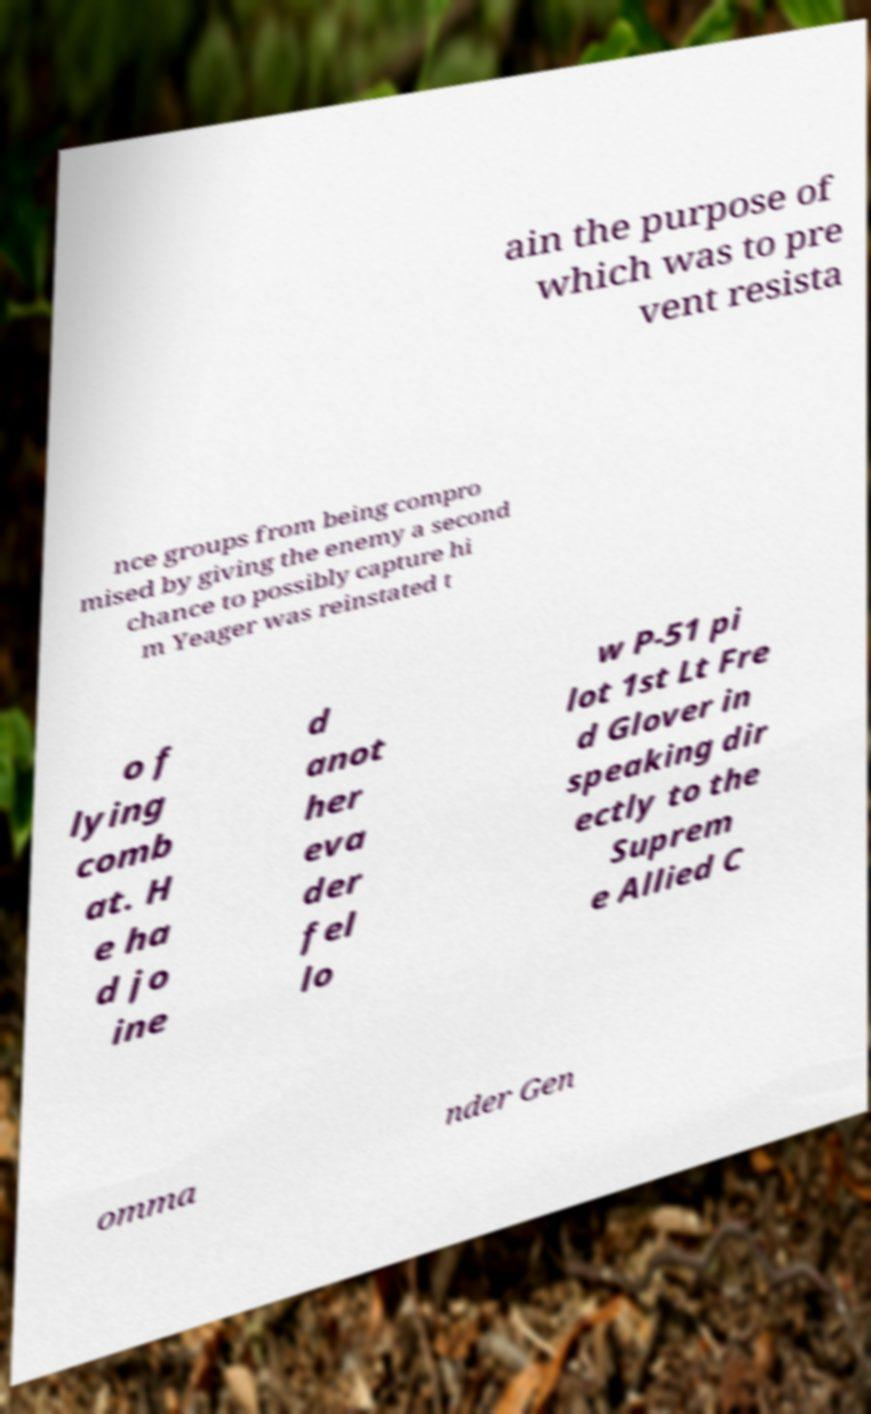What messages or text are displayed in this image? I need them in a readable, typed format. ain the purpose of which was to pre vent resista nce groups from being compro mised by giving the enemy a second chance to possibly capture hi m Yeager was reinstated t o f lying comb at. H e ha d jo ine d anot her eva der fel lo w P-51 pi lot 1st Lt Fre d Glover in speaking dir ectly to the Suprem e Allied C omma nder Gen 